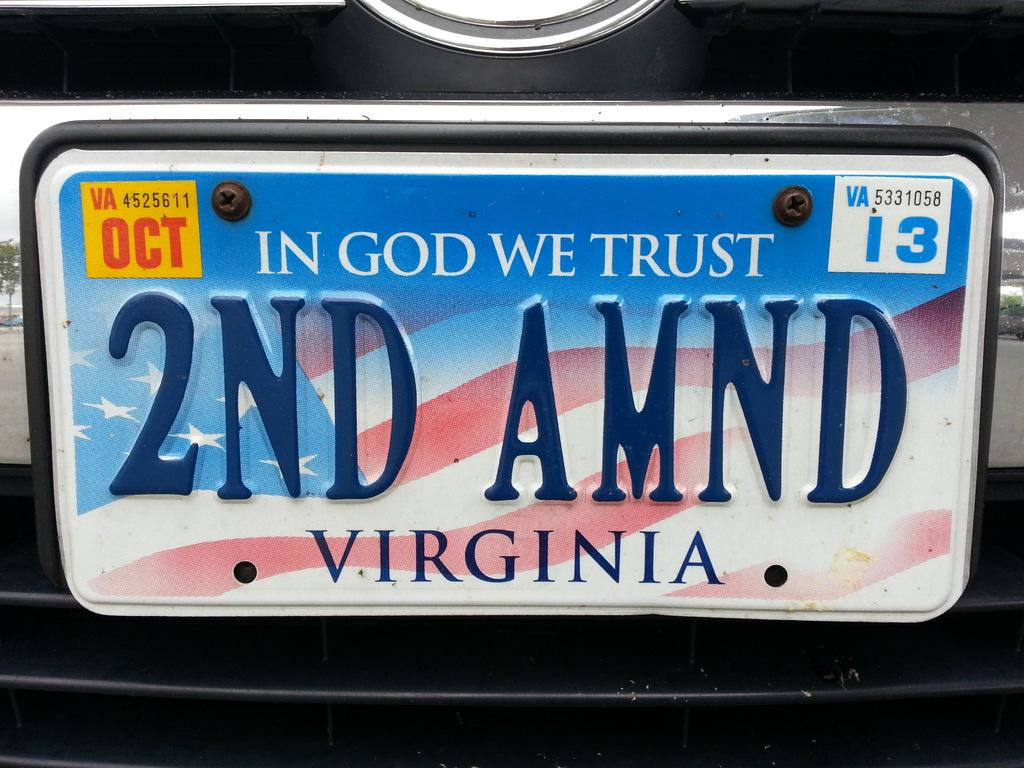<image>
Write a terse but informative summary of the picture. An american flag themed Virginia state license plate. 